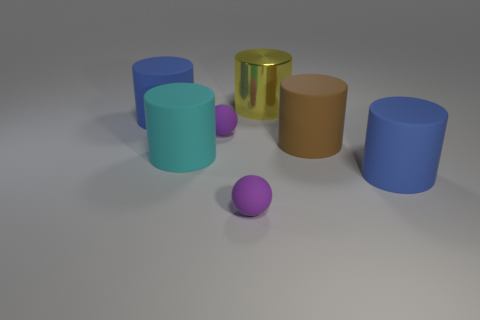Subtract all large cyan cylinders. How many cylinders are left? 4 Subtract 3 cylinders. How many cylinders are left? 2 Subtract all brown cylinders. How many cylinders are left? 4 Add 3 blue rubber cylinders. How many objects exist? 10 Subtract all red cylinders. Subtract all purple spheres. How many cylinders are left? 5 Subtract all cylinders. How many objects are left? 2 Add 3 large cylinders. How many large cylinders are left? 8 Add 4 brown objects. How many brown objects exist? 5 Subtract 1 yellow cylinders. How many objects are left? 6 Subtract all tiny purple balls. Subtract all big blue cylinders. How many objects are left? 3 